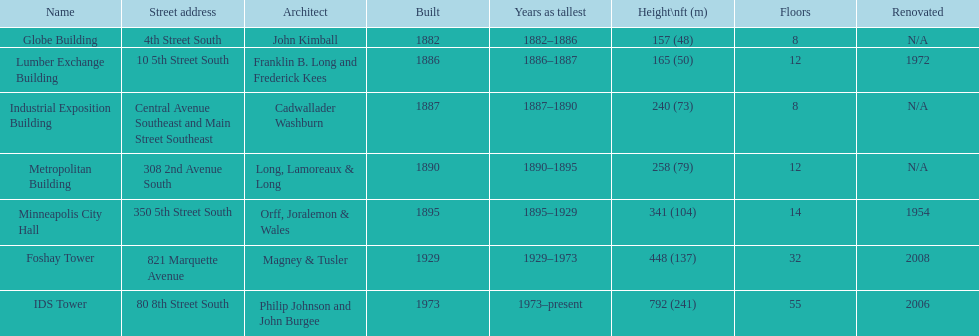Which building has the same number of floors as the lumber exchange building? Metropolitan Building. 